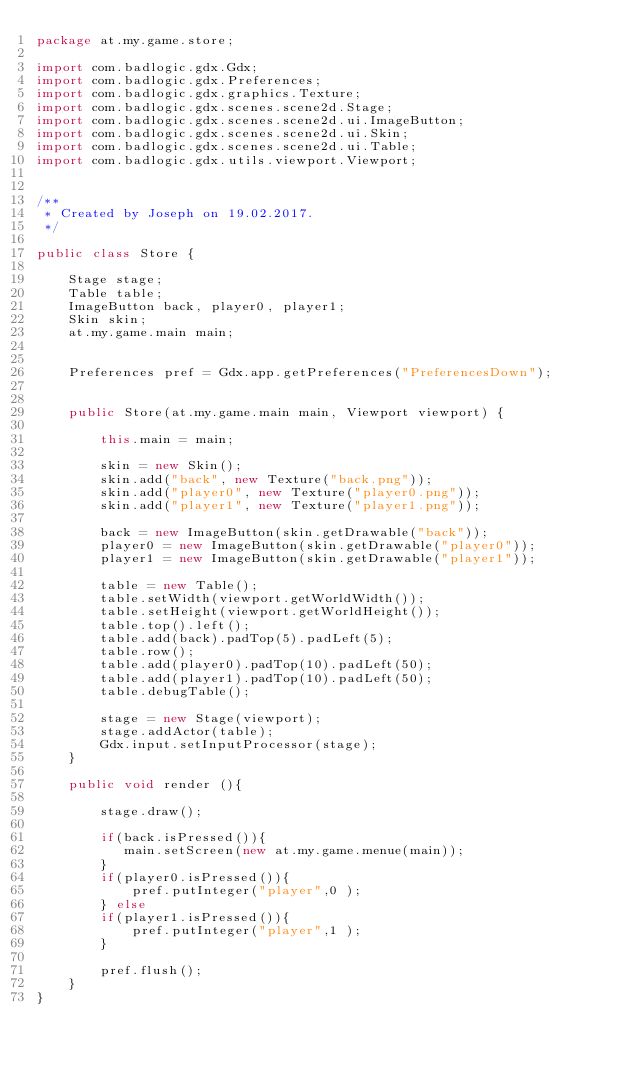<code> <loc_0><loc_0><loc_500><loc_500><_Java_>package at.my.game.store;

import com.badlogic.gdx.Gdx;
import com.badlogic.gdx.Preferences;
import com.badlogic.gdx.graphics.Texture;
import com.badlogic.gdx.scenes.scene2d.Stage;
import com.badlogic.gdx.scenes.scene2d.ui.ImageButton;
import com.badlogic.gdx.scenes.scene2d.ui.Skin;
import com.badlogic.gdx.scenes.scene2d.ui.Table;
import com.badlogic.gdx.utils.viewport.Viewport;


/**
 * Created by Joseph on 19.02.2017.
 */

public class Store {

    Stage stage;
    Table table;
    ImageButton back, player0, player1;
    Skin skin;
    at.my.game.main main;


    Preferences pref = Gdx.app.getPreferences("PreferencesDown");


    public Store(at.my.game.main main, Viewport viewport) {

        this.main = main;

        skin = new Skin();
        skin.add("back", new Texture("back.png"));
        skin.add("player0", new Texture("player0.png"));
        skin.add("player1", new Texture("player1.png"));

        back = new ImageButton(skin.getDrawable("back"));
        player0 = new ImageButton(skin.getDrawable("player0"));
        player1 = new ImageButton(skin.getDrawable("player1"));

        table = new Table();
        table.setWidth(viewport.getWorldWidth());
        table.setHeight(viewport.getWorldHeight());
        table.top().left();
        table.add(back).padTop(5).padLeft(5);
        table.row();
        table.add(player0).padTop(10).padLeft(50);
        table.add(player1).padTop(10).padLeft(50);
        table.debugTable();

        stage = new Stage(viewport);
        stage.addActor(table);
        Gdx.input.setInputProcessor(stage);
    }

    public void render (){

        stage.draw();

        if(back.isPressed()){
           main.setScreen(new at.my.game.menue(main));
        }
        if(player0.isPressed()){
            pref.putInteger("player",0 );
        } else
        if(player1.isPressed()){
            pref.putInteger("player",1 );
        }

        pref.flush();
    }
}
</code> 